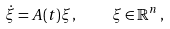Convert formula to latex. <formula><loc_0><loc_0><loc_500><loc_500>\dot { \xi } = A ( t ) \xi \, , \quad \xi \in \mathbb { R } ^ { n } \, ,</formula> 